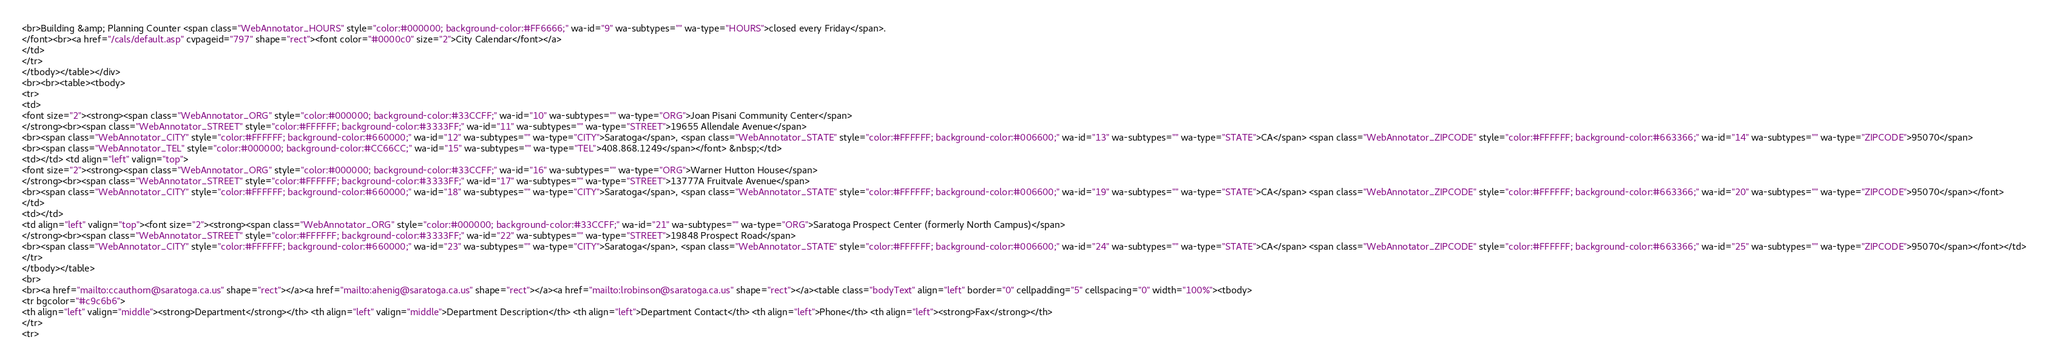<code> <loc_0><loc_0><loc_500><loc_500><_HTML_><br>Building &amp; Planning Counter <span class="WebAnnotator_HOURS" style="color:#000000; background-color:#FF6666;" wa-id="9" wa-subtypes="" wa-type="HOURS">closed every Friday</span>.
</font><br><a href="/cals/default.asp" cvpageid="797" shape="rect"><font color="#0000c0" size="2">City Calendar</font></a>
</td>
</tr>
</tbody></table></div>
<br><br><table><tbody>
<tr>
<td>
<font size="2"><strong><span class="WebAnnotator_ORG" style="color:#000000; background-color:#33CCFF;" wa-id="10" wa-subtypes="" wa-type="ORG">Joan Pisani Community Center</span>
</strong><br><span class="WebAnnotator_STREET" style="color:#FFFFFF; background-color:#3333FF;" wa-id="11" wa-subtypes="" wa-type="STREET">19655 Allendale Avenue</span>
<br><span class="WebAnnotator_CITY" style="color:#FFFFFF; background-color:#660000;" wa-id="12" wa-subtypes="" wa-type="CITY">Saratoga</span>, <span class="WebAnnotator_STATE" style="color:#FFFFFF; background-color:#006600;" wa-id="13" wa-subtypes="" wa-type="STATE">CA</span> <span class="WebAnnotator_ZIPCODE" style="color:#FFFFFF; background-color:#663366;" wa-id="14" wa-subtypes="" wa-type="ZIPCODE">95070</span>
<br><span class="WebAnnotator_TEL" style="color:#000000; background-color:#CC66CC;" wa-id="15" wa-subtypes="" wa-type="TEL">408.868.1249</span></font> &nbsp;</td>
<td></td> <td align="left" valign="top">
<font size="2"><strong><span class="WebAnnotator_ORG" style="color:#000000; background-color:#33CCFF;" wa-id="16" wa-subtypes="" wa-type="ORG">Warner Hutton House</span>
</strong><br><span class="WebAnnotator_STREET" style="color:#FFFFFF; background-color:#3333FF;" wa-id="17" wa-subtypes="" wa-type="STREET">13777A Fruitvale Avenue</span>
<br><span class="WebAnnotator_CITY" style="color:#FFFFFF; background-color:#660000;" wa-id="18" wa-subtypes="" wa-type="CITY">Saratoga</span>, <span class="WebAnnotator_STATE" style="color:#FFFFFF; background-color:#006600;" wa-id="19" wa-subtypes="" wa-type="STATE">CA</span> <span class="WebAnnotator_ZIPCODE" style="color:#FFFFFF; background-color:#663366;" wa-id="20" wa-subtypes="" wa-type="ZIPCODE">95070</span></font>
</td>
<td></td>
<td align="left" valign="top"><font size="2"><strong><span class="WebAnnotator_ORG" style="color:#000000; background-color:#33CCFF;" wa-id="21" wa-subtypes="" wa-type="ORG">Saratoga Prospect Center (formerly North Campus)</span>
</strong><br><span class="WebAnnotator_STREET" style="color:#FFFFFF; background-color:#3333FF;" wa-id="22" wa-subtypes="" wa-type="STREET">19848 Prospect Road</span>
<br><span class="WebAnnotator_CITY" style="color:#FFFFFF; background-color:#660000;" wa-id="23" wa-subtypes="" wa-type="CITY">Saratoga</span>, <span class="WebAnnotator_STATE" style="color:#FFFFFF; background-color:#006600;" wa-id="24" wa-subtypes="" wa-type="STATE">CA</span> <span class="WebAnnotator_ZIPCODE" style="color:#FFFFFF; background-color:#663366;" wa-id="25" wa-subtypes="" wa-type="ZIPCODE">95070</span></font></td>
</tr>
</tbody></table>
<br>
<br><a href="mailto:ccauthorn@saratoga.ca.us" shape="rect"></a><a href="mailto:ahenig@saratoga.ca.us" shape="rect"></a><a href="mailto:lrobinson@saratoga.ca.us" shape="rect"></a><table class="bodyText" align="left" border="0" cellpadding="5" cellspacing="0" width="100%"><tbody>
<tr bgcolor="#c9c6b6">
<th align="left" valign="middle"><strong>Department</strong></th> <th align="left" valign="middle">Department Description</th> <th align="left">Department Contact</th> <th align="left">Phone</th> <th align="left"><strong>Fax</strong></th>
</tr>
<tr></code> 